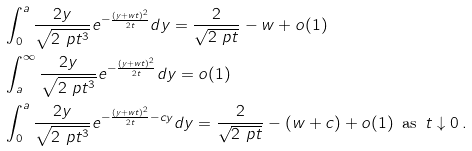Convert formula to latex. <formula><loc_0><loc_0><loc_500><loc_500>& \int _ { 0 } ^ { a } \frac { 2 y } { \sqrt { 2 \ p t ^ { 3 } } } e ^ { - \frac { ( y + w t ) ^ { 2 } } { 2 t } } d y = \frac { 2 } { \sqrt { 2 \ p t } } - w + o ( 1 ) \\ & \int _ { a } ^ { \infty } \frac { 2 y } { \sqrt { 2 \ p t ^ { 3 } } } e ^ { - \frac { ( y + w t ) ^ { 2 } } { 2 t } } d y = o ( 1 ) \\ & \int _ { 0 } ^ { a } \frac { 2 y } { \sqrt { 2 \ p t ^ { 3 } } } e ^ { - \frac { ( y + w t ) ^ { 2 } } { 2 t } - c y } d y = \frac { 2 } { \sqrt { 2 \ p t } } - ( w + c ) + o ( 1 ) \, \text { as } \, t \downarrow 0 \, .</formula> 